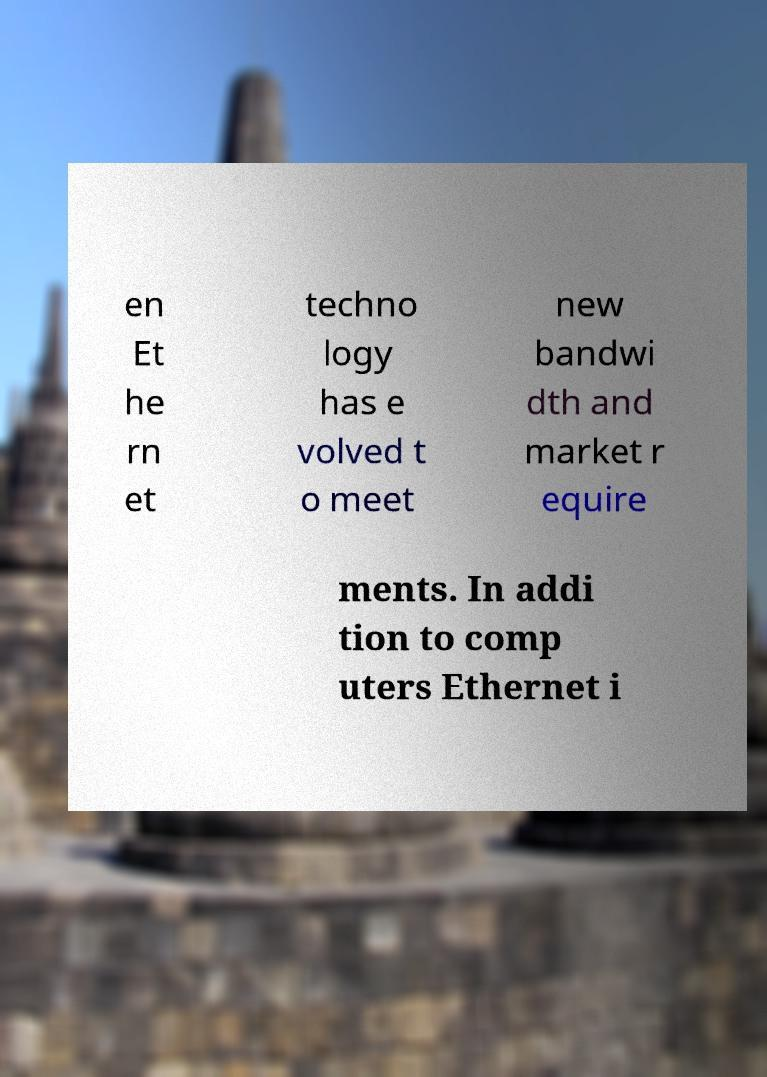Please read and relay the text visible in this image. What does it say? en Et he rn et techno logy has e volved t o meet new bandwi dth and market r equire ments. In addi tion to comp uters Ethernet i 